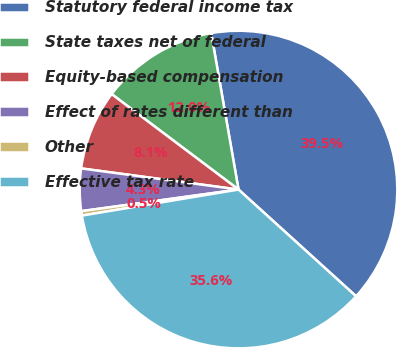Convert chart. <chart><loc_0><loc_0><loc_500><loc_500><pie_chart><fcel>Statutory federal income tax<fcel>State taxes net of federal<fcel>Equity-based compensation<fcel>Effect of rates different than<fcel>Other<fcel>Effective tax rate<nl><fcel>39.48%<fcel>11.98%<fcel>8.14%<fcel>4.3%<fcel>0.45%<fcel>35.64%<nl></chart> 